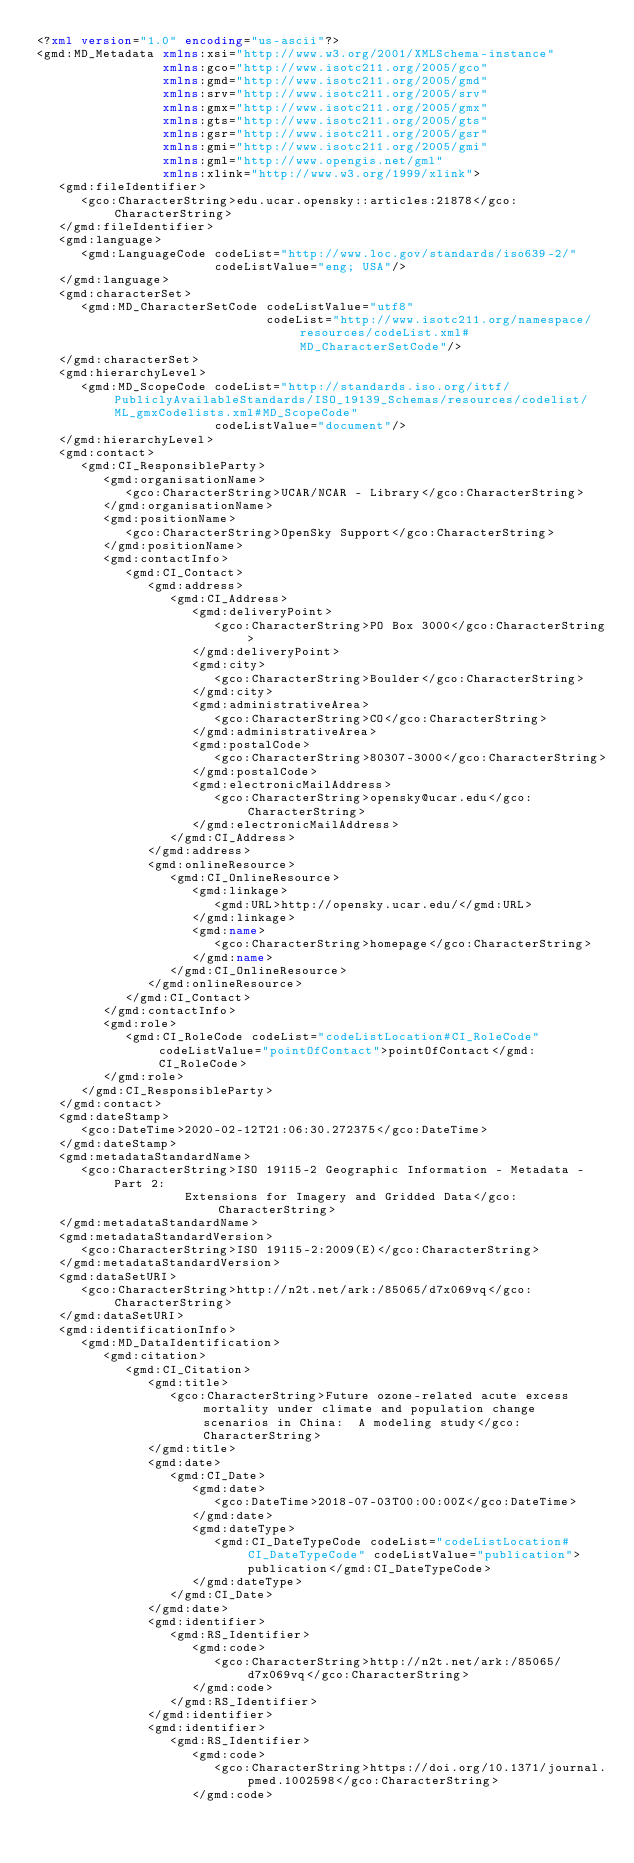Convert code to text. <code><loc_0><loc_0><loc_500><loc_500><_XML_><?xml version="1.0" encoding="us-ascii"?>
<gmd:MD_Metadata xmlns:xsi="http://www.w3.org/2001/XMLSchema-instance"
                 xmlns:gco="http://www.isotc211.org/2005/gco"
                 xmlns:gmd="http://www.isotc211.org/2005/gmd"
                 xmlns:srv="http://www.isotc211.org/2005/srv"
                 xmlns:gmx="http://www.isotc211.org/2005/gmx"
                 xmlns:gts="http://www.isotc211.org/2005/gts"
                 xmlns:gsr="http://www.isotc211.org/2005/gsr"
                 xmlns:gmi="http://www.isotc211.org/2005/gmi"
                 xmlns:gml="http://www.opengis.net/gml"
                 xmlns:xlink="http://www.w3.org/1999/xlink">
   <gmd:fileIdentifier>
      <gco:CharacterString>edu.ucar.opensky::articles:21878</gco:CharacterString>
   </gmd:fileIdentifier>
   <gmd:language>
      <gmd:LanguageCode codeList="http://www.loc.gov/standards/iso639-2/"
                        codeListValue="eng; USA"/>
   </gmd:language>
   <gmd:characterSet>
      <gmd:MD_CharacterSetCode codeListValue="utf8"
                               codeList="http://www.isotc211.org/namespace/resources/codeList.xml#MD_CharacterSetCode"/>
   </gmd:characterSet>
   <gmd:hierarchyLevel>
      <gmd:MD_ScopeCode codeList="http://standards.iso.org/ittf/PubliclyAvailableStandards/ISO_19139_Schemas/resources/codelist/ML_gmxCodelists.xml#MD_ScopeCode"
                        codeListValue="document"/>
   </gmd:hierarchyLevel>
   <gmd:contact>
      <gmd:CI_ResponsibleParty>
         <gmd:organisationName>
            <gco:CharacterString>UCAR/NCAR - Library</gco:CharacterString>
         </gmd:organisationName>
         <gmd:positionName>
            <gco:CharacterString>OpenSky Support</gco:CharacterString>
         </gmd:positionName>
         <gmd:contactInfo>
            <gmd:CI_Contact>
               <gmd:address>
                  <gmd:CI_Address>
                     <gmd:deliveryPoint>
                        <gco:CharacterString>PO Box 3000</gco:CharacterString>
                     </gmd:deliveryPoint>
                     <gmd:city>
                        <gco:CharacterString>Boulder</gco:CharacterString>
                     </gmd:city>
                     <gmd:administrativeArea>
                        <gco:CharacterString>CO</gco:CharacterString>
                     </gmd:administrativeArea>
                     <gmd:postalCode>
                        <gco:CharacterString>80307-3000</gco:CharacterString>
                     </gmd:postalCode>
                     <gmd:electronicMailAddress>
                        <gco:CharacterString>opensky@ucar.edu</gco:CharacterString>
                     </gmd:electronicMailAddress>
                  </gmd:CI_Address>
               </gmd:address>
               <gmd:onlineResource>
                  <gmd:CI_OnlineResource>
                     <gmd:linkage>
                        <gmd:URL>http://opensky.ucar.edu/</gmd:URL>
                     </gmd:linkage>
                     <gmd:name>
                        <gco:CharacterString>homepage</gco:CharacterString>
                     </gmd:name>
                  </gmd:CI_OnlineResource>
               </gmd:onlineResource>
            </gmd:CI_Contact>
         </gmd:contactInfo>
         <gmd:role>
            <gmd:CI_RoleCode codeList="codeListLocation#CI_RoleCode" codeListValue="pointOfContact">pointOfContact</gmd:CI_RoleCode>
         </gmd:role>
      </gmd:CI_ResponsibleParty>
   </gmd:contact>
   <gmd:dateStamp>
      <gco:DateTime>2020-02-12T21:06:30.272375</gco:DateTime>
   </gmd:dateStamp>
   <gmd:metadataStandardName>
      <gco:CharacterString>ISO 19115-2 Geographic Information - Metadata - Part 2:
                    Extensions for Imagery and Gridded Data</gco:CharacterString>
   </gmd:metadataStandardName>
   <gmd:metadataStandardVersion>
      <gco:CharacterString>ISO 19115-2:2009(E)</gco:CharacterString>
   </gmd:metadataStandardVersion>
   <gmd:dataSetURI>
      <gco:CharacterString>http://n2t.net/ark:/85065/d7x069vq</gco:CharacterString>
   </gmd:dataSetURI>
   <gmd:identificationInfo>
      <gmd:MD_DataIdentification>
         <gmd:citation>
            <gmd:CI_Citation>
               <gmd:title>
                  <gco:CharacterString>Future ozone-related acute excess mortality under climate and population change scenarios in China:  A modeling study</gco:CharacterString>
               </gmd:title>
               <gmd:date>
                  <gmd:CI_Date>
                     <gmd:date>
                        <gco:DateTime>2018-07-03T00:00:00Z</gco:DateTime>
                     </gmd:date>
                     <gmd:dateType>
                        <gmd:CI_DateTypeCode codeList="codeListLocation#CI_DateTypeCode" codeListValue="publication">publication</gmd:CI_DateTypeCode>
                     </gmd:dateType>
                  </gmd:CI_Date>
               </gmd:date>
               <gmd:identifier>
                  <gmd:RS_Identifier>
                     <gmd:code>
                        <gco:CharacterString>http://n2t.net/ark:/85065/d7x069vq</gco:CharacterString>
                     </gmd:code>
                  </gmd:RS_Identifier>
               </gmd:identifier>
               <gmd:identifier>
                  <gmd:RS_Identifier>
                     <gmd:code>
                        <gco:CharacterString>https://doi.org/10.1371/journal.pmed.1002598</gco:CharacterString>
                     </gmd:code></code> 